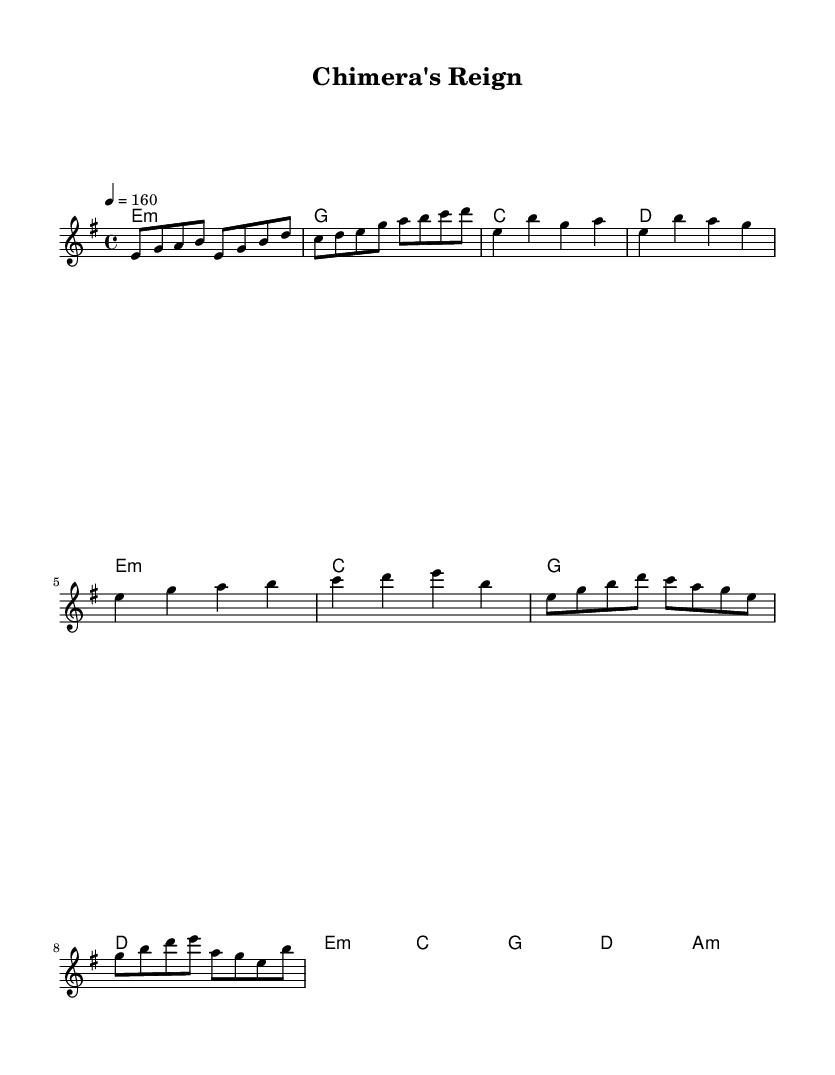What is the key signature of this music? The key signature indicates E minor, as there is one sharp (F#). This is derived from the global section where "e" is used as the key note, which confirms a minor key signature with one sharp.
Answer: E minor What is the time signature of this piece? The time signature shown is 4/4, which is indicated in the global section of the code. It specifies that there are four beats in each measure and a quarter note gets one beat.
Answer: 4/4 What is the tempo marking of the song? The tempo marking is specified as quarter note equals 160 beats per minute in the global section. This indicates a fast-paced performance.
Answer: 160 How many measures are in the verse section? The verse section has four measures as indicated by the music notation in the melody part, specifically outlined in the verse section. Each separate line indicates a new measure.
Answer: 4 What is the last chord in the chorus? The last chord in the chorus section is A minor, as shown in the harmonies section. It is the final chord listed after the sequence of chords in that part of the piece.
Answer: A minor Which note appears most frequently in the melody? The note E appears most frequently throughout the melody section. Each occurrence can be counted, and E is present numerous times compared to other notes.
Answer: E 